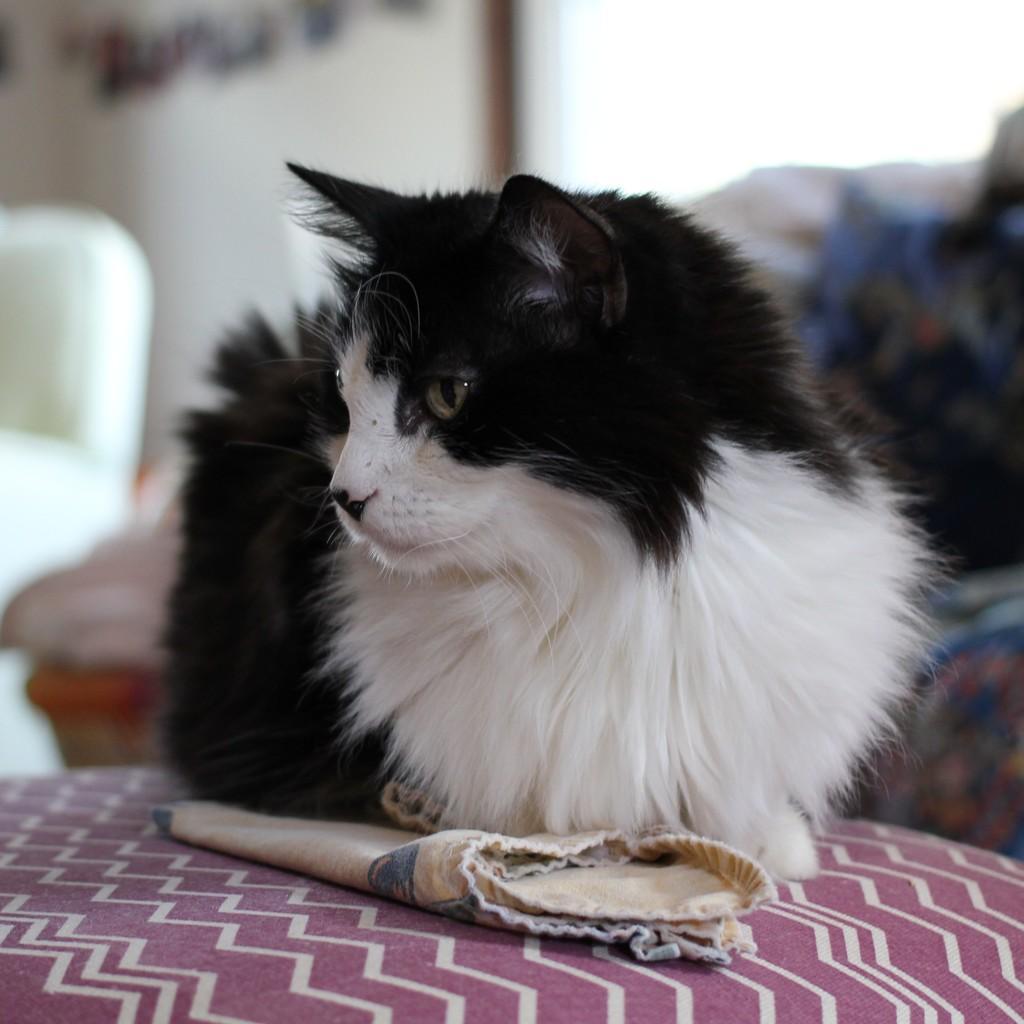In one or two sentences, can you explain what this image depicts? In the center of the image we can see a cat on the surface. We can also see a cloth beside it. On the backside we can see a sofa with cushion and a wall. 